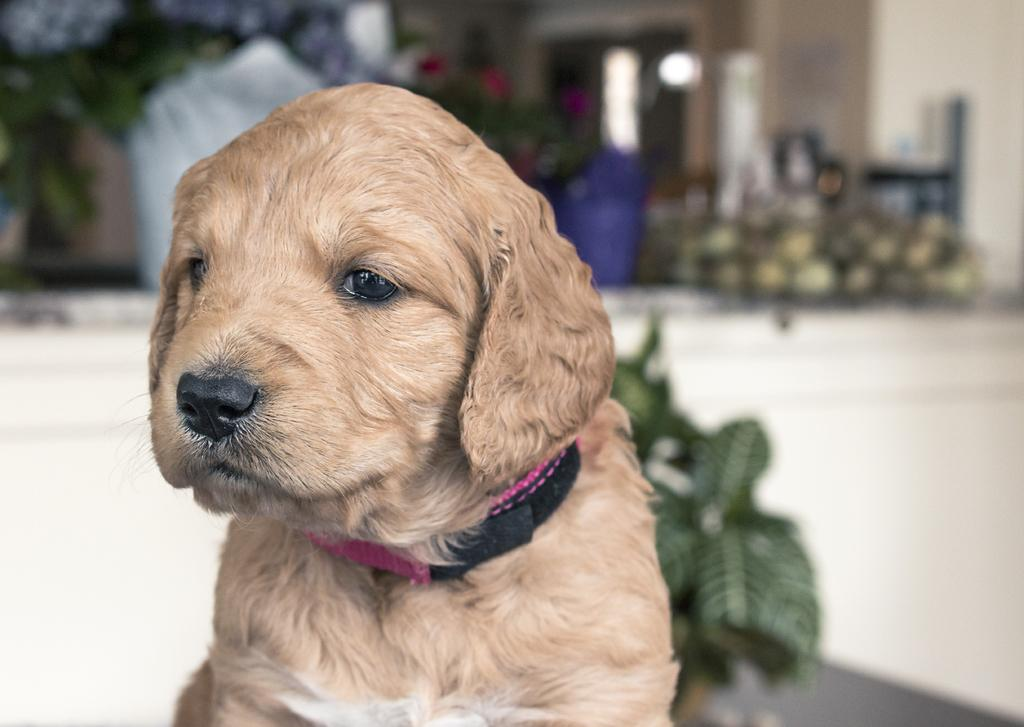What type of animal is in the image? There is a brown puppy in the image. Can you describe the background of the image? The background of the image is blurred. How many frogs can be seen in the image? There are no frogs present in the image. What other things can be seen in the image besides the brown puppy? The image only contains the brown puppy, so there are no other things visible. 